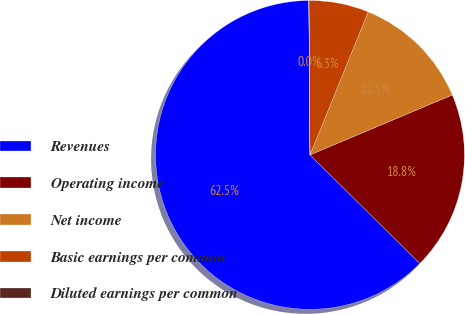Convert chart to OTSL. <chart><loc_0><loc_0><loc_500><loc_500><pie_chart><fcel>Revenues<fcel>Operating income<fcel>Net income<fcel>Basic earnings per common<fcel>Diluted earnings per common<nl><fcel>62.48%<fcel>18.75%<fcel>12.5%<fcel>6.26%<fcel>0.01%<nl></chart> 